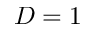Convert formula to latex. <formula><loc_0><loc_0><loc_500><loc_500>D = 1</formula> 